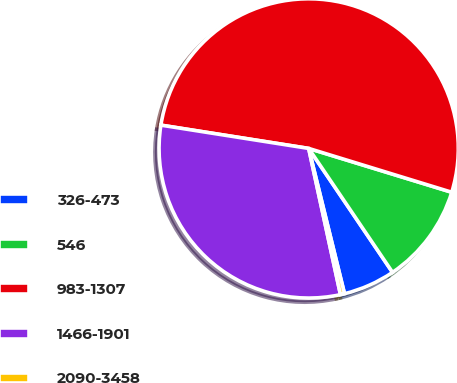Convert chart. <chart><loc_0><loc_0><loc_500><loc_500><pie_chart><fcel>326-473<fcel>546<fcel>983-1307<fcel>1466-1901<fcel>2090-3458<nl><fcel>5.62%<fcel>10.8%<fcel>52.24%<fcel>30.89%<fcel>0.44%<nl></chart> 